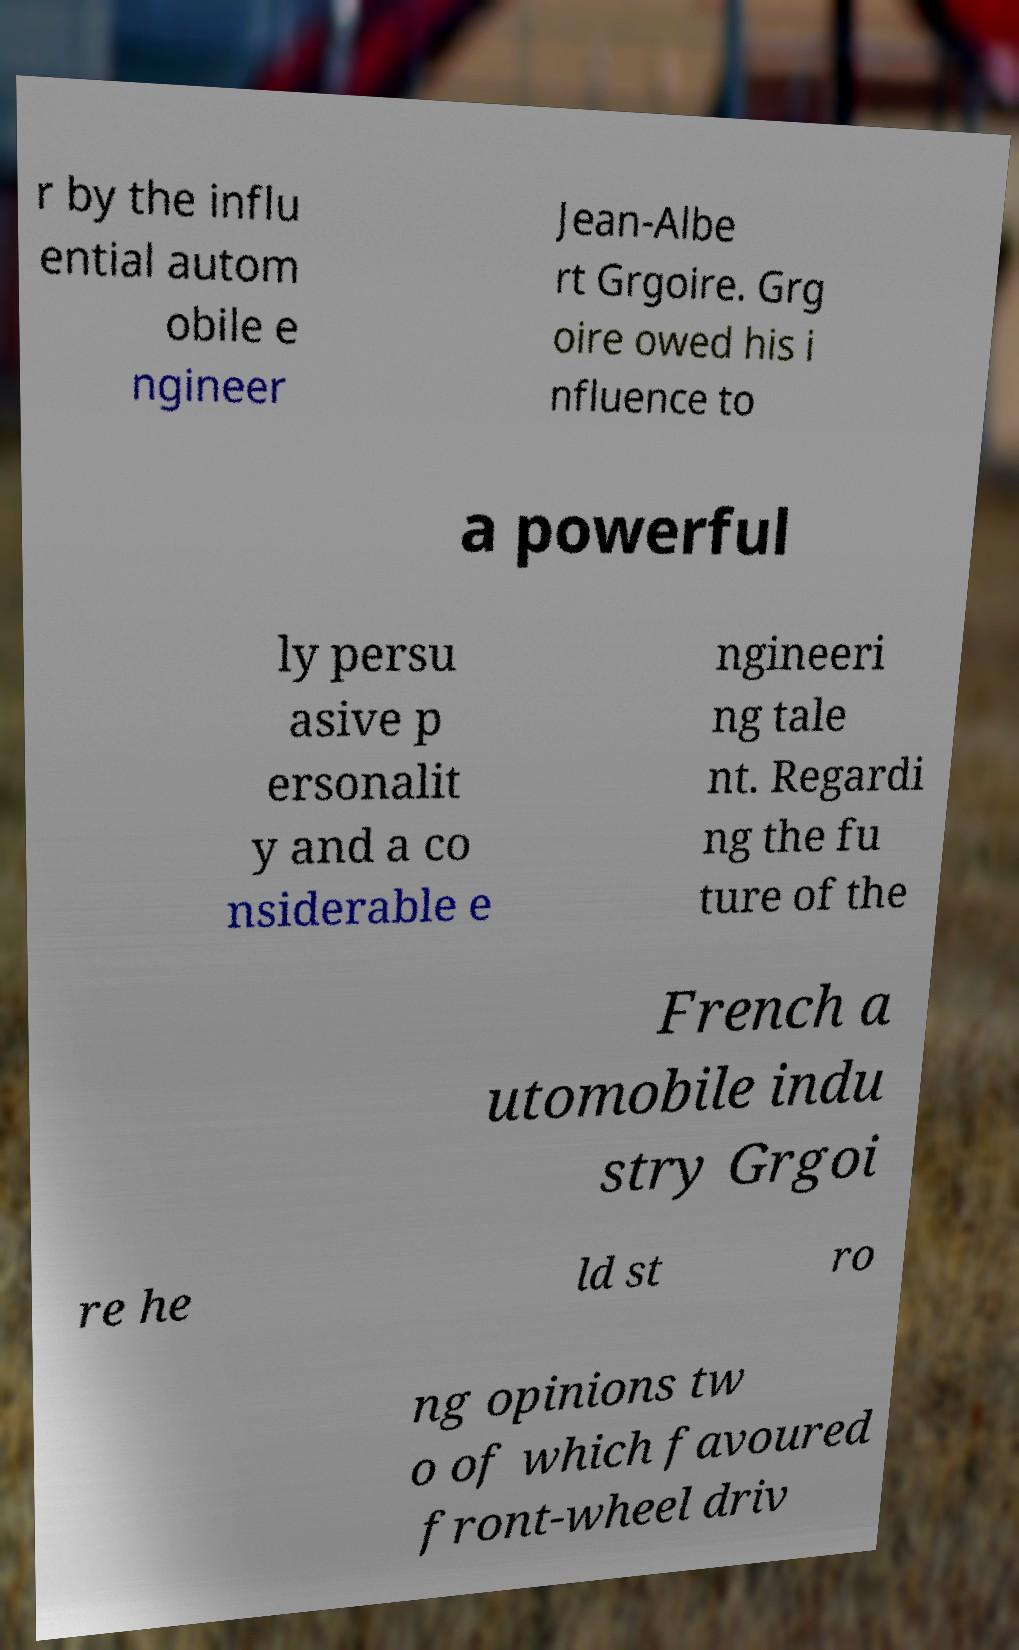Please identify and transcribe the text found in this image. r by the influ ential autom obile e ngineer Jean-Albe rt Grgoire. Grg oire owed his i nfluence to a powerful ly persu asive p ersonalit y and a co nsiderable e ngineeri ng tale nt. Regardi ng the fu ture of the French a utomobile indu stry Grgoi re he ld st ro ng opinions tw o of which favoured front-wheel driv 